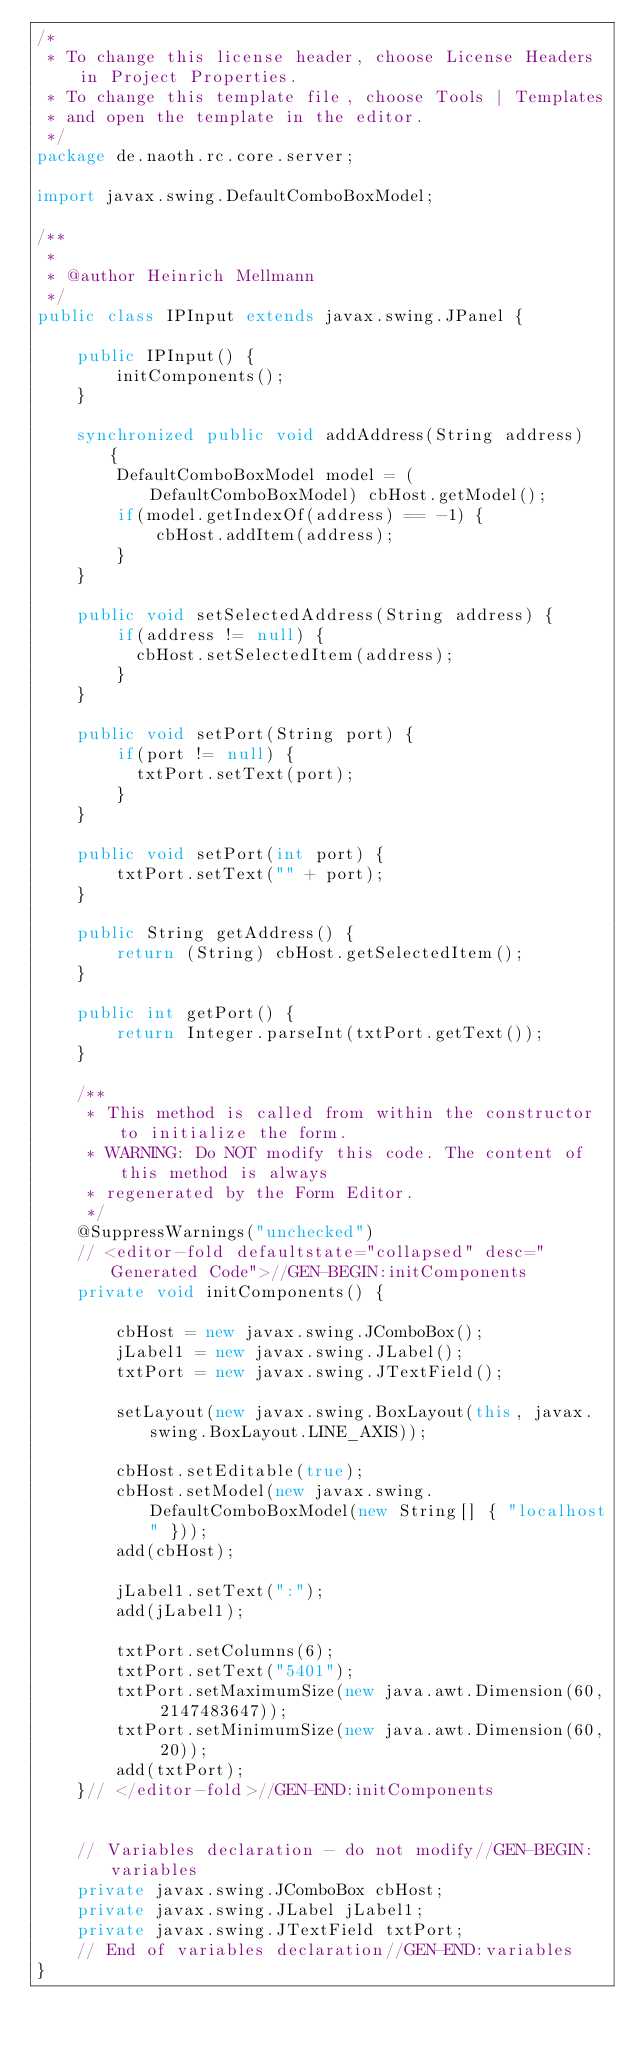<code> <loc_0><loc_0><loc_500><loc_500><_Java_>/*
 * To change this license header, choose License Headers in Project Properties.
 * To change this template file, choose Tools | Templates
 * and open the template in the editor.
 */
package de.naoth.rc.core.server;

import javax.swing.DefaultComboBoxModel;

/**
 *
 * @author Heinrich Mellmann
 */
public class IPInput extends javax.swing.JPanel {

    public IPInput() {
        initComponents();
    }

    synchronized public void addAddress(String address)  {
        DefaultComboBoxModel model = (DefaultComboBoxModel) cbHost.getModel();
        if(model.getIndexOf(address) == -1) {
            cbHost.addItem(address);
        }
    }
    
    public void setSelectedAddress(String address) {
        if(address != null) {
          cbHost.setSelectedItem(address);
        }
    }
    
    public void setPort(String port) {
        if(port != null) {
          txtPort.setText(port);
        }
    }
    
    public void setPort(int port) {
        txtPort.setText("" + port);
    }
    
    public String getAddress() {
        return (String) cbHost.getSelectedItem();
    }
    
    public int getPort() {
        return Integer.parseInt(txtPort.getText());
    }
    
    /**
     * This method is called from within the constructor to initialize the form.
     * WARNING: Do NOT modify this code. The content of this method is always
     * regenerated by the Form Editor.
     */
    @SuppressWarnings("unchecked")
    // <editor-fold defaultstate="collapsed" desc="Generated Code">//GEN-BEGIN:initComponents
    private void initComponents() {

        cbHost = new javax.swing.JComboBox();
        jLabel1 = new javax.swing.JLabel();
        txtPort = new javax.swing.JTextField();

        setLayout(new javax.swing.BoxLayout(this, javax.swing.BoxLayout.LINE_AXIS));

        cbHost.setEditable(true);
        cbHost.setModel(new javax.swing.DefaultComboBoxModel(new String[] { "localhost" }));
        add(cbHost);

        jLabel1.setText(":");
        add(jLabel1);

        txtPort.setColumns(6);
        txtPort.setText("5401");
        txtPort.setMaximumSize(new java.awt.Dimension(60, 2147483647));
        txtPort.setMinimumSize(new java.awt.Dimension(60, 20));
        add(txtPort);
    }// </editor-fold>//GEN-END:initComponents


    // Variables declaration - do not modify//GEN-BEGIN:variables
    private javax.swing.JComboBox cbHost;
    private javax.swing.JLabel jLabel1;
    private javax.swing.JTextField txtPort;
    // End of variables declaration//GEN-END:variables
}
</code> 